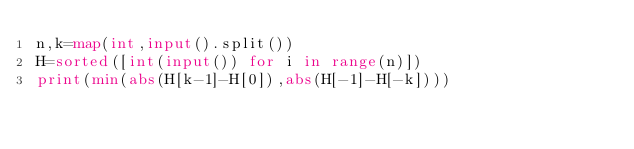Convert code to text. <code><loc_0><loc_0><loc_500><loc_500><_Python_>n,k=map(int,input().split())
H=sorted([int(input()) for i in range(n)])
print(min(abs(H[k-1]-H[0]),abs(H[-1]-H[-k])))
</code> 